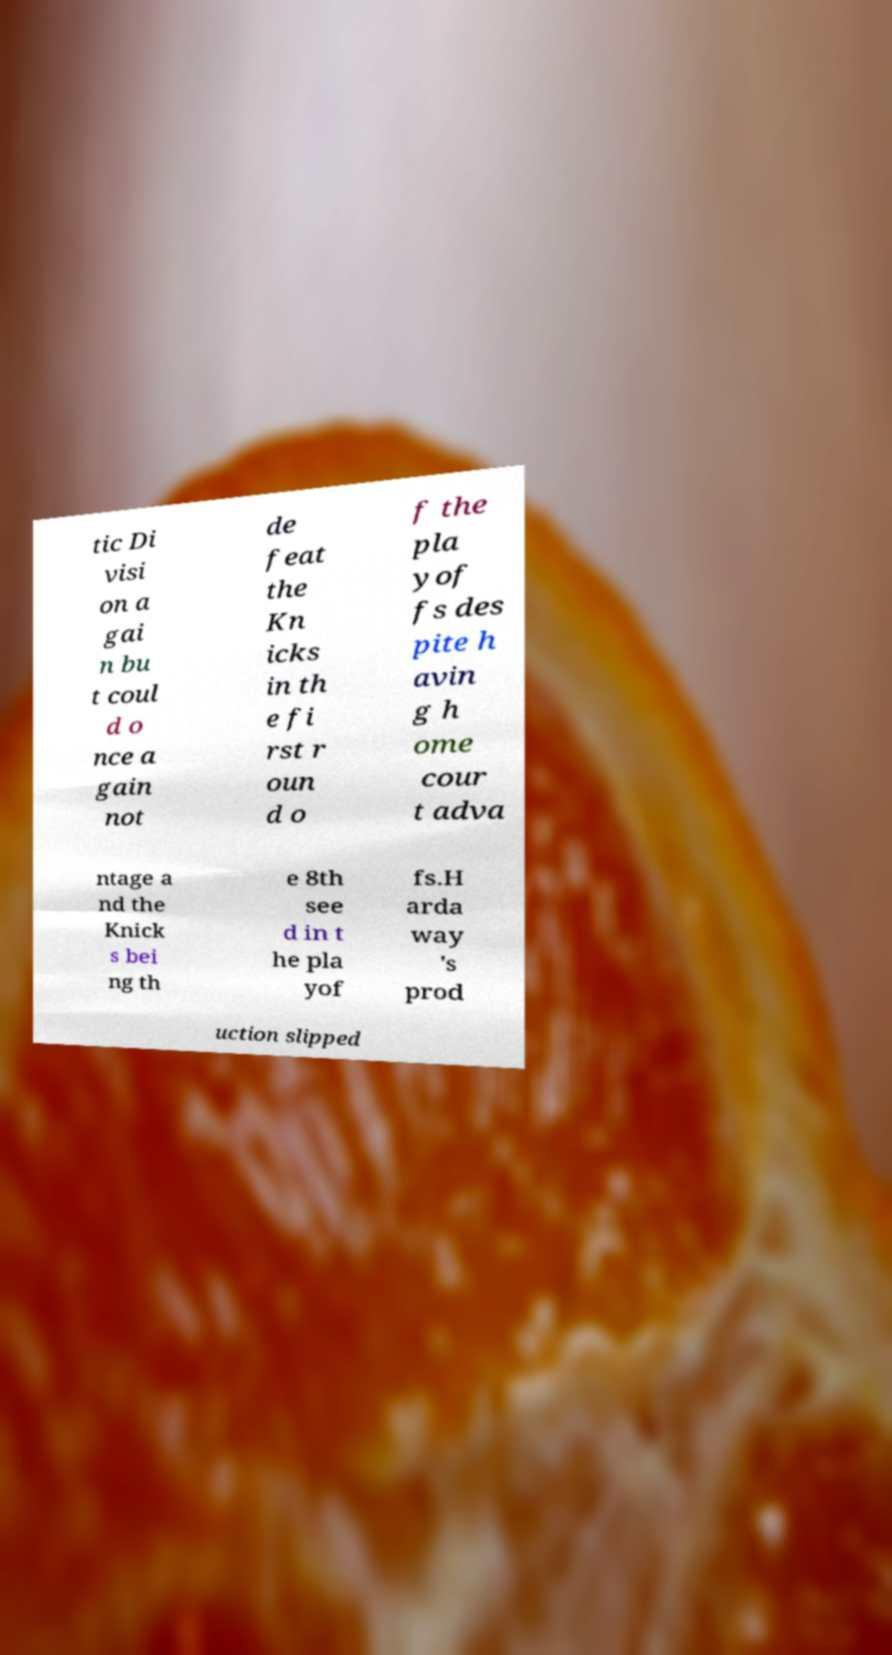Could you assist in decoding the text presented in this image and type it out clearly? tic Di visi on a gai n bu t coul d o nce a gain not de feat the Kn icks in th e fi rst r oun d o f the pla yof fs des pite h avin g h ome cour t adva ntage a nd the Knick s bei ng th e 8th see d in t he pla yof fs.H arda way 's prod uction slipped 